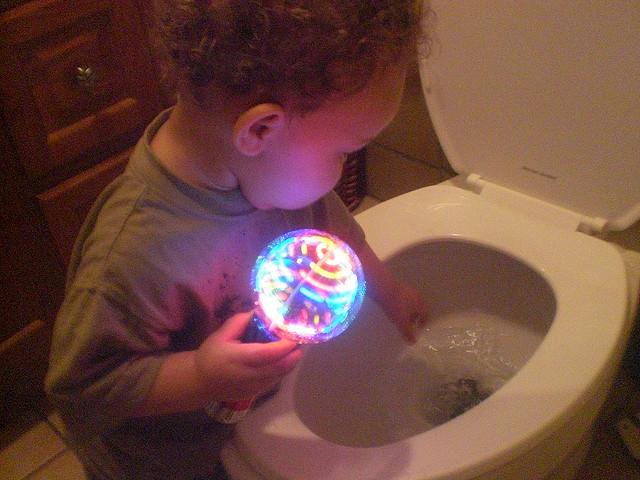Is this a light up toy?
Give a very brief answer. Yes. Is the person an adult or child?
Be succinct. Child. What is the child looking at?
Concise answer only. Toilet. 